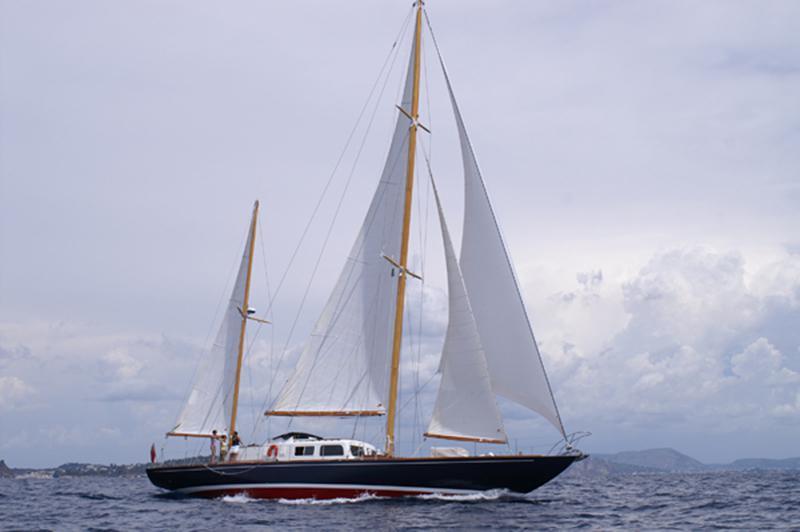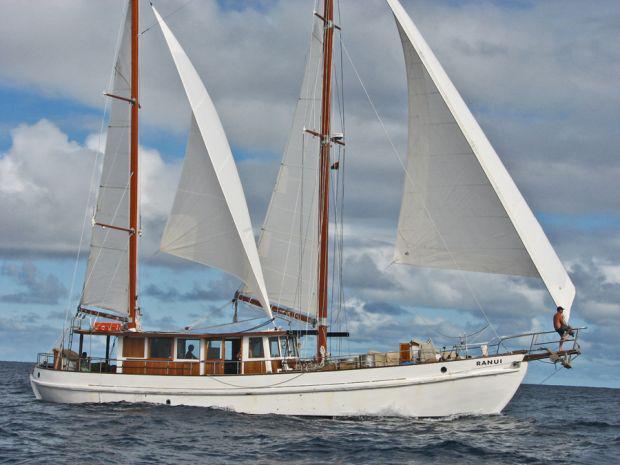The first image is the image on the left, the second image is the image on the right. Considering the images on both sides, is "The two boats are heading towards each other." valid? Answer yes or no. No. The first image is the image on the left, the second image is the image on the right. Given the left and right images, does the statement "One sailboat has a dark exterior and no more than four sails." hold true? Answer yes or no. Yes. The first image is the image on the left, the second image is the image on the right. For the images shown, is this caption "The boat in the image on the right is lighter in color than the boat in the image on the left." true? Answer yes or no. Yes. 